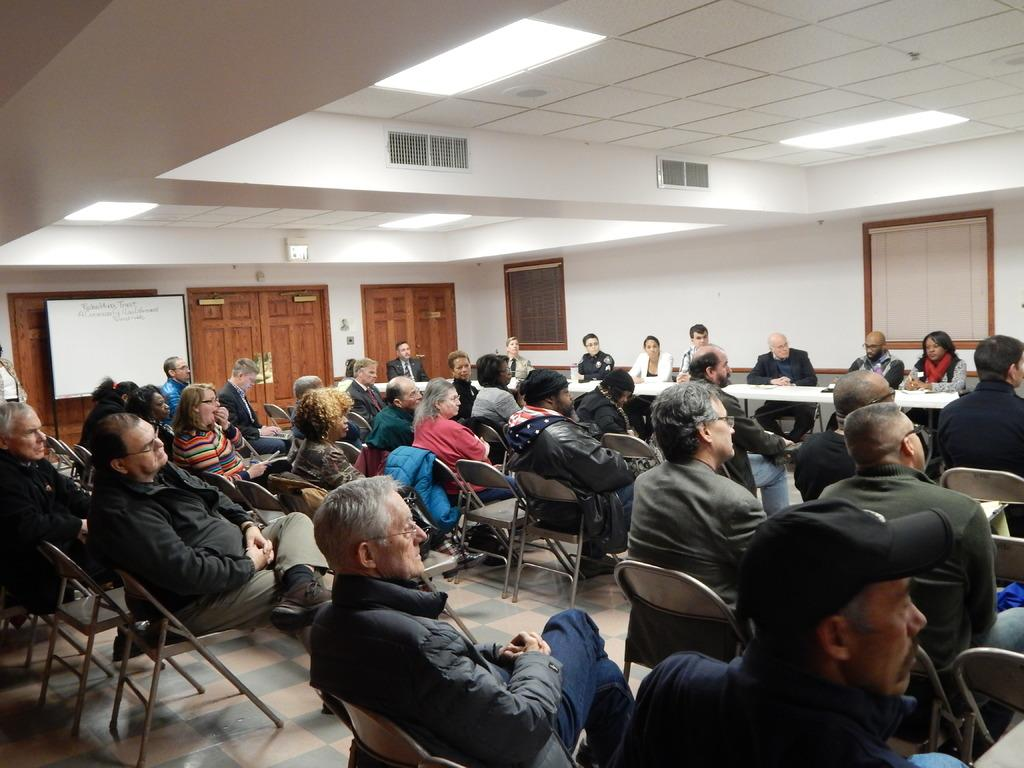What are the people in the image doing? The people in the image are sitting in chairs. Can you describe the gender of the people in the image? There are men and women in the image. What can be seen in the background of the image? There is a wall in the background of the image. What type of pets are present at the party in the image? There is no party or pets present in the image. What is the reason for the protest in the image? There is no protest in the image; it features people sitting in chairs. 